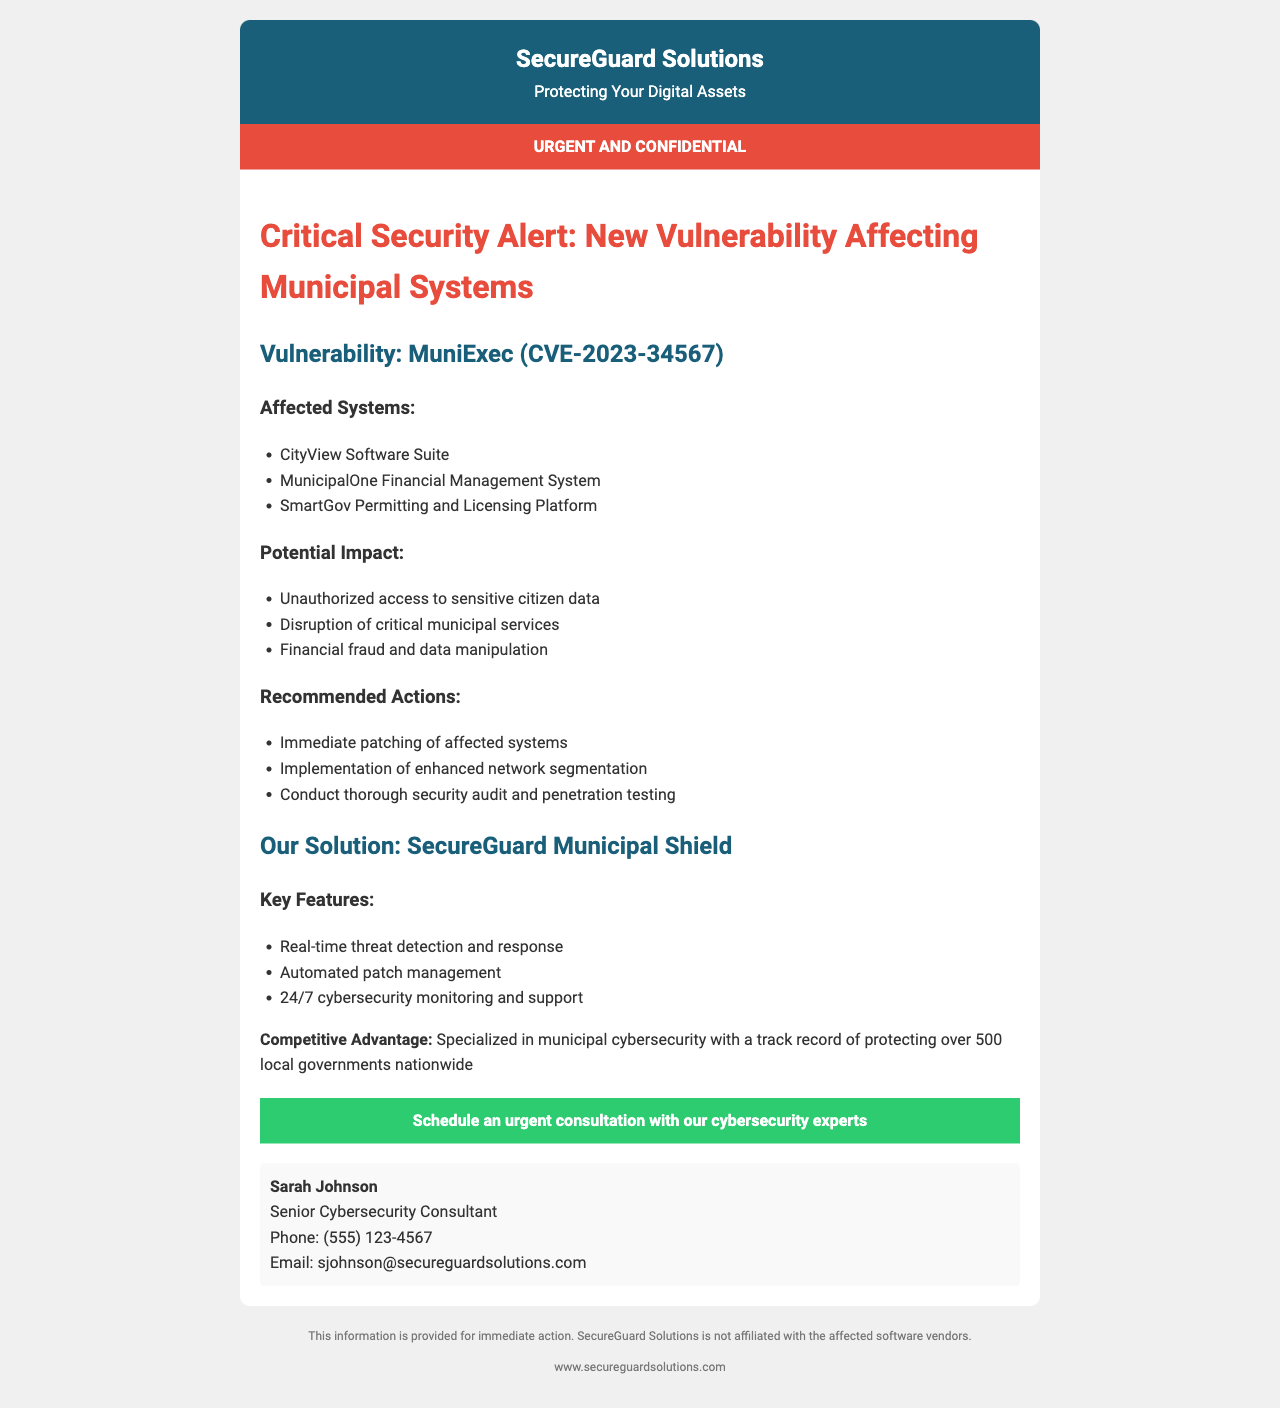what is the vulnerability identifier? The document specifies the vulnerability identifier as "CVE-2023-34567".
Answer: CVE-2023-34567 how many affected systems are listed? The document lists three affected systems.
Answer: three what is one potential impact of the vulnerability? The document mentions "Unauthorized access to sensitive citizen data" as a potential impact.
Answer: Unauthorized access to sensitive citizen data what is the name of the solution offered? The document refers to the solution as "SecureGuard Municipal Shield".
Answer: SecureGuard Municipal Shield who is the senior cybersecurity consultant? The document states the senior cybersecurity consultant is "Sarah Johnson".
Answer: Sarah Johnson what is one recommended action for municipalities? The document recommends "Immediate patching of affected systems".
Answer: Immediate patching of affected systems what feature does the solution provide for cybersecurity monitoring? The document states the solution provides "24/7 cybersecurity monitoring and support".
Answer: 24/7 cybersecurity monitoring and support what color is used for the confidential section in the document? The confidential section of the document uses the color red.
Answer: red 